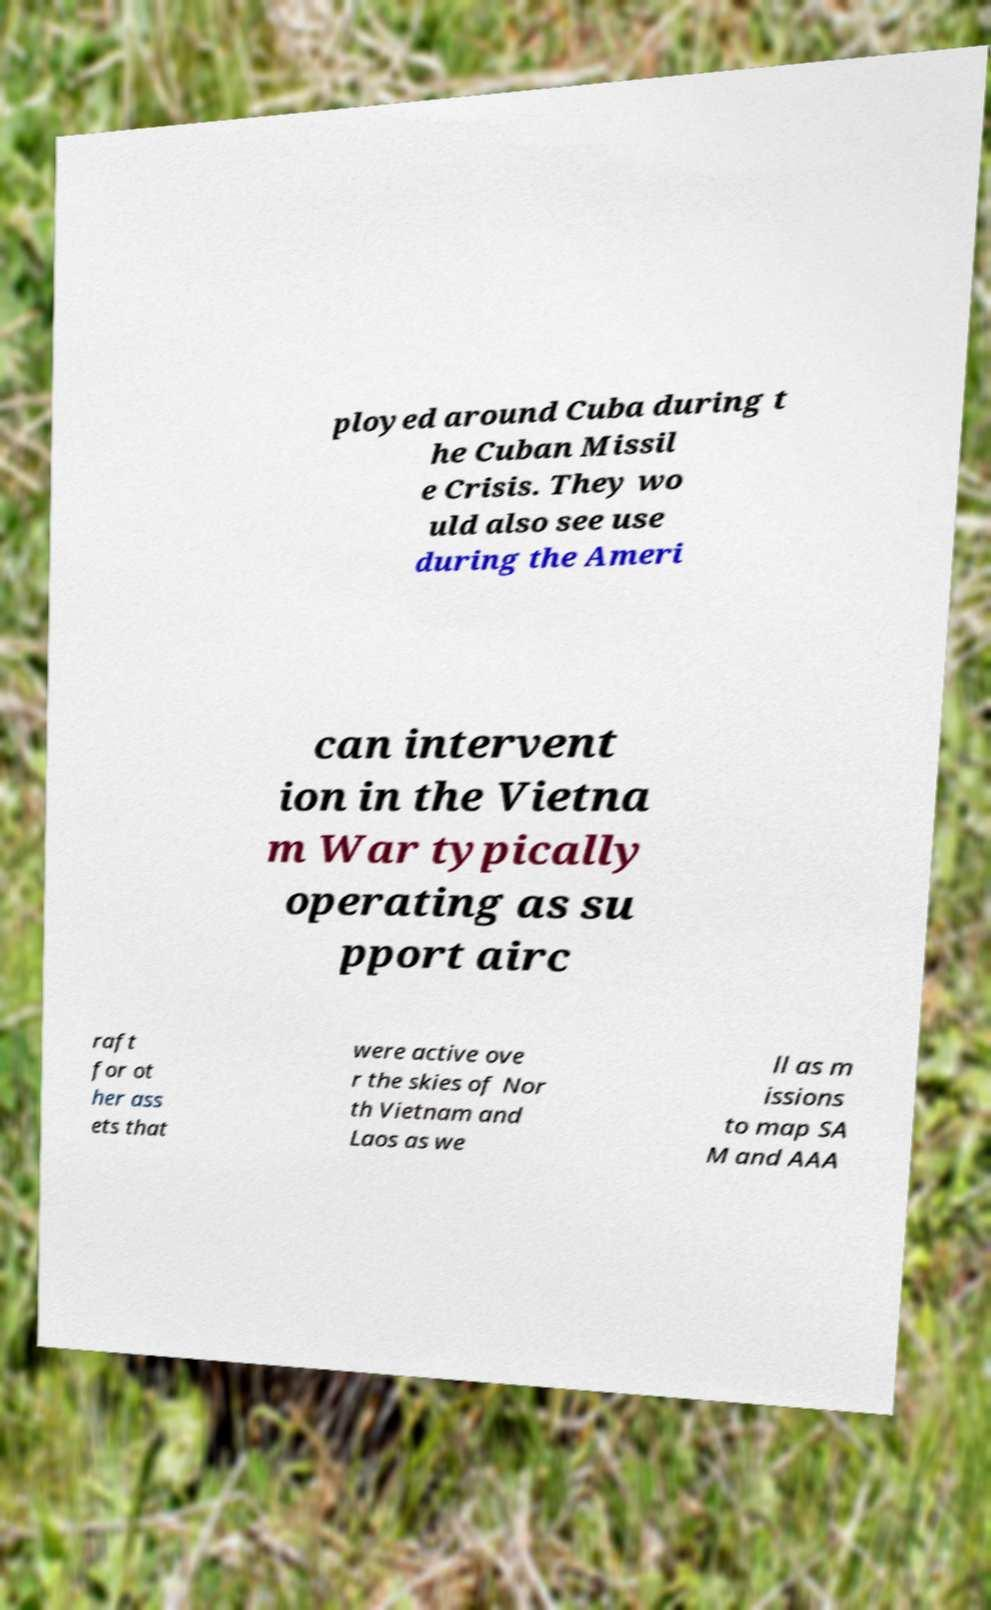What messages or text are displayed in this image? I need them in a readable, typed format. ployed around Cuba during t he Cuban Missil e Crisis. They wo uld also see use during the Ameri can intervent ion in the Vietna m War typically operating as su pport airc raft for ot her ass ets that were active ove r the skies of Nor th Vietnam and Laos as we ll as m issions to map SA M and AAA 